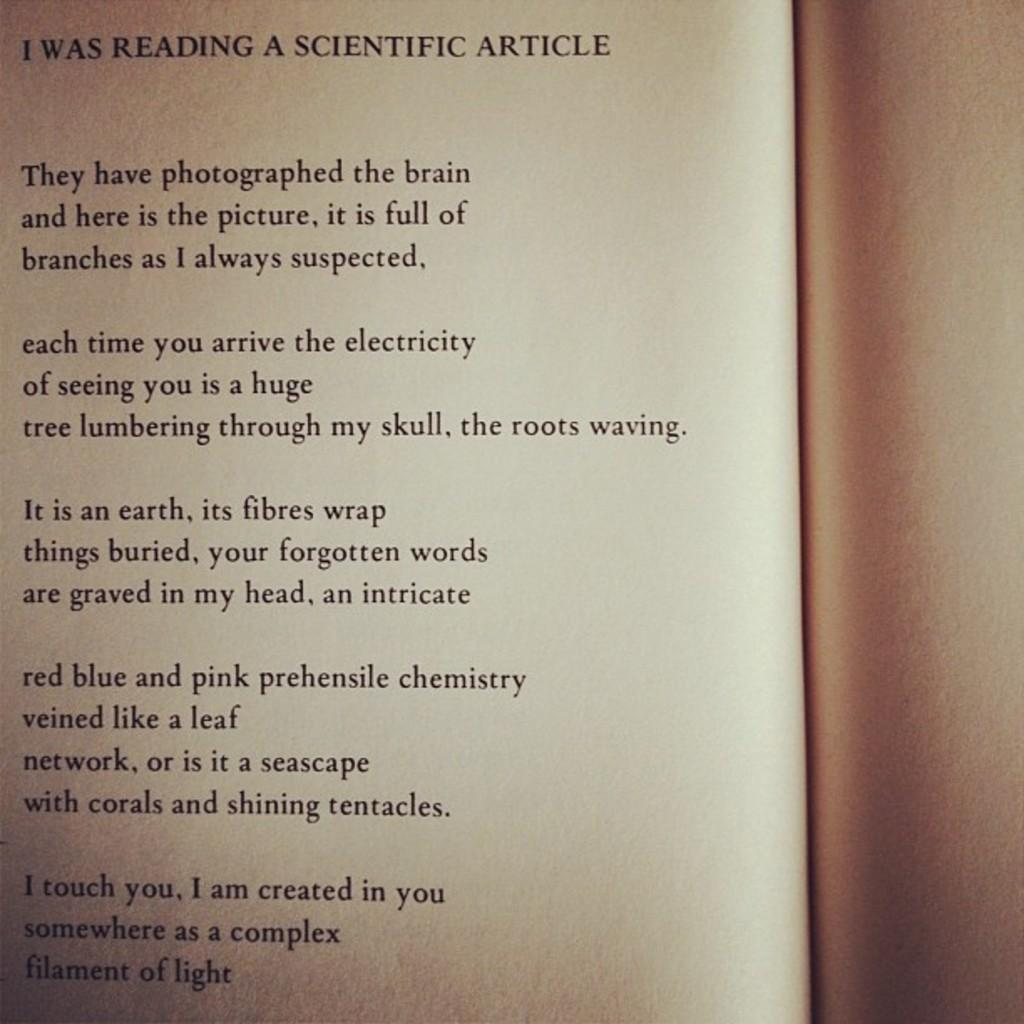<image>
Provide a brief description of the given image. A page is titled I Was Reading A Scientific Article and has a poem below it. 